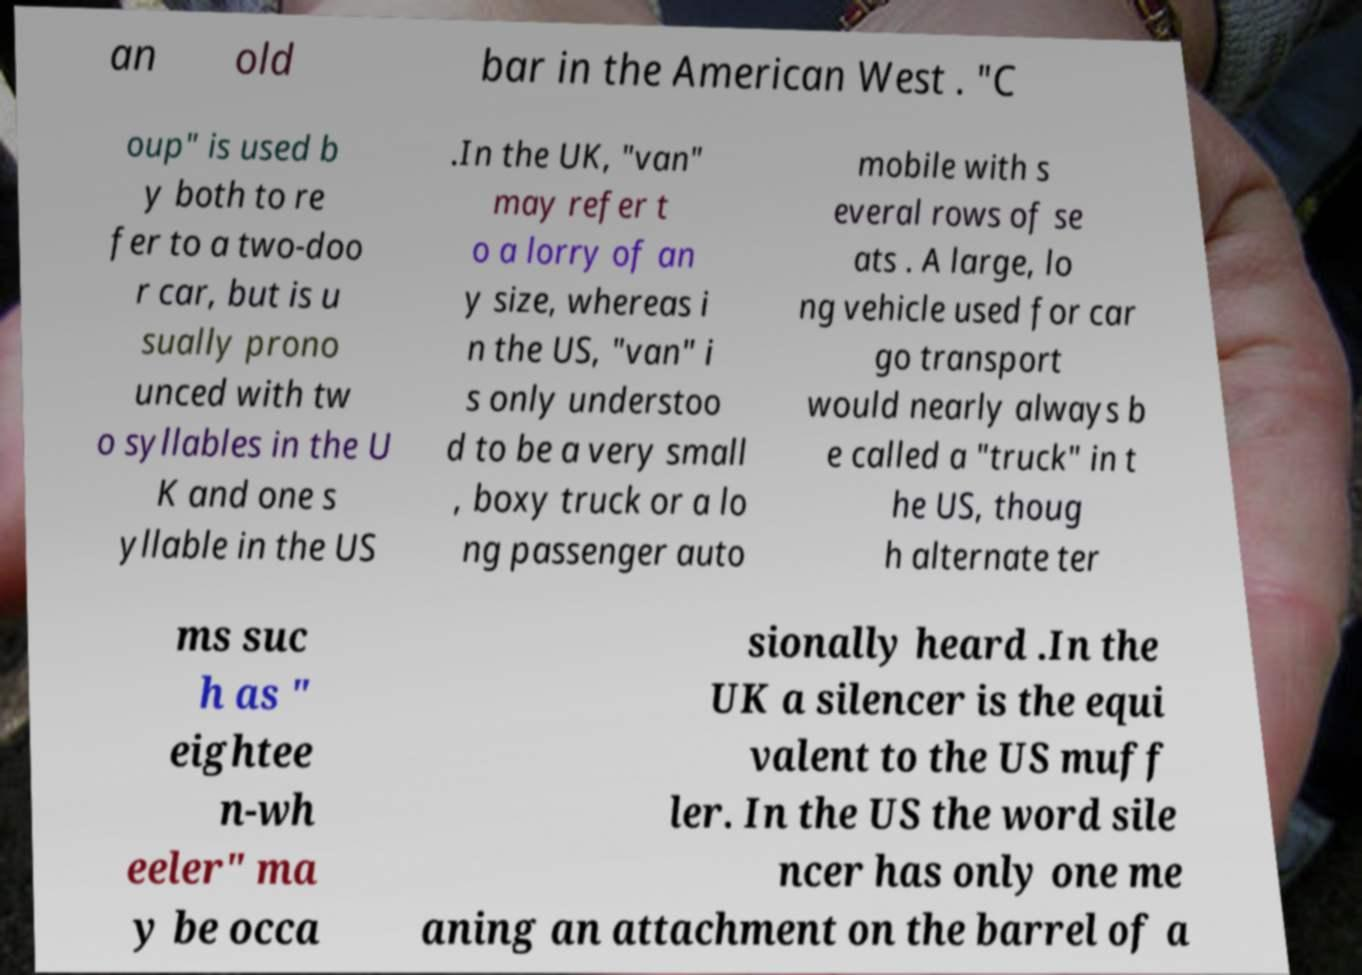There's text embedded in this image that I need extracted. Can you transcribe it verbatim? an old bar in the American West . "C oup" is used b y both to re fer to a two-doo r car, but is u sually prono unced with tw o syllables in the U K and one s yllable in the US .In the UK, "van" may refer t o a lorry of an y size, whereas i n the US, "van" i s only understoo d to be a very small , boxy truck or a lo ng passenger auto mobile with s everal rows of se ats . A large, lo ng vehicle used for car go transport would nearly always b e called a "truck" in t he US, thoug h alternate ter ms suc h as " eightee n-wh eeler" ma y be occa sionally heard .In the UK a silencer is the equi valent to the US muff ler. In the US the word sile ncer has only one me aning an attachment on the barrel of a 